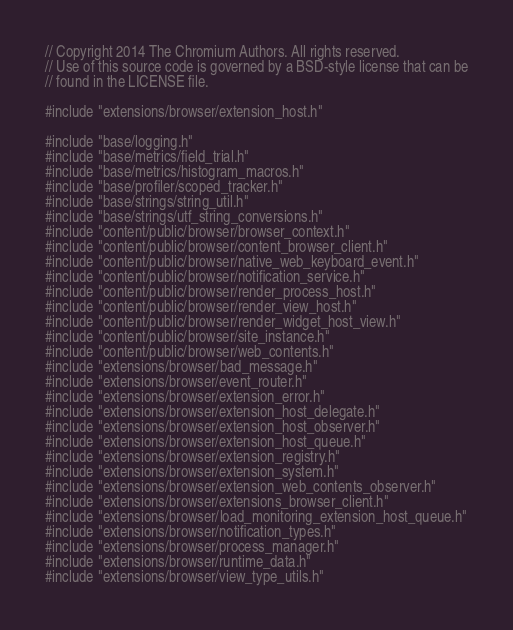<code> <loc_0><loc_0><loc_500><loc_500><_C++_>// Copyright 2014 The Chromium Authors. All rights reserved.
// Use of this source code is governed by a BSD-style license that can be
// found in the LICENSE file.

#include "extensions/browser/extension_host.h"

#include "base/logging.h"
#include "base/metrics/field_trial.h"
#include "base/metrics/histogram_macros.h"
#include "base/profiler/scoped_tracker.h"
#include "base/strings/string_util.h"
#include "base/strings/utf_string_conversions.h"
#include "content/public/browser/browser_context.h"
#include "content/public/browser/content_browser_client.h"
#include "content/public/browser/native_web_keyboard_event.h"
#include "content/public/browser/notification_service.h"
#include "content/public/browser/render_process_host.h"
#include "content/public/browser/render_view_host.h"
#include "content/public/browser/render_widget_host_view.h"
#include "content/public/browser/site_instance.h"
#include "content/public/browser/web_contents.h"
#include "extensions/browser/bad_message.h"
#include "extensions/browser/event_router.h"
#include "extensions/browser/extension_error.h"
#include "extensions/browser/extension_host_delegate.h"
#include "extensions/browser/extension_host_observer.h"
#include "extensions/browser/extension_host_queue.h"
#include "extensions/browser/extension_registry.h"
#include "extensions/browser/extension_system.h"
#include "extensions/browser/extension_web_contents_observer.h"
#include "extensions/browser/extensions_browser_client.h"
#include "extensions/browser/load_monitoring_extension_host_queue.h"
#include "extensions/browser/notification_types.h"
#include "extensions/browser/process_manager.h"
#include "extensions/browser/runtime_data.h"
#include "extensions/browser/view_type_utils.h"</code> 